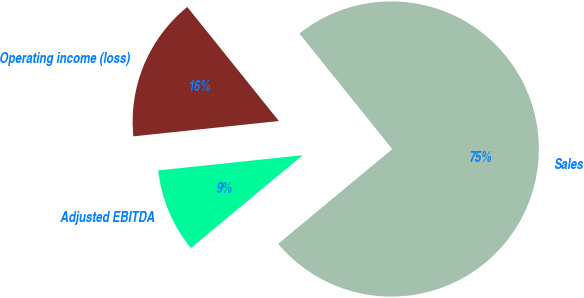<chart> <loc_0><loc_0><loc_500><loc_500><pie_chart><fcel>Sales<fcel>Operating income (loss)<fcel>Adjusted EBITDA<nl><fcel>74.74%<fcel>15.9%<fcel>9.36%<nl></chart> 